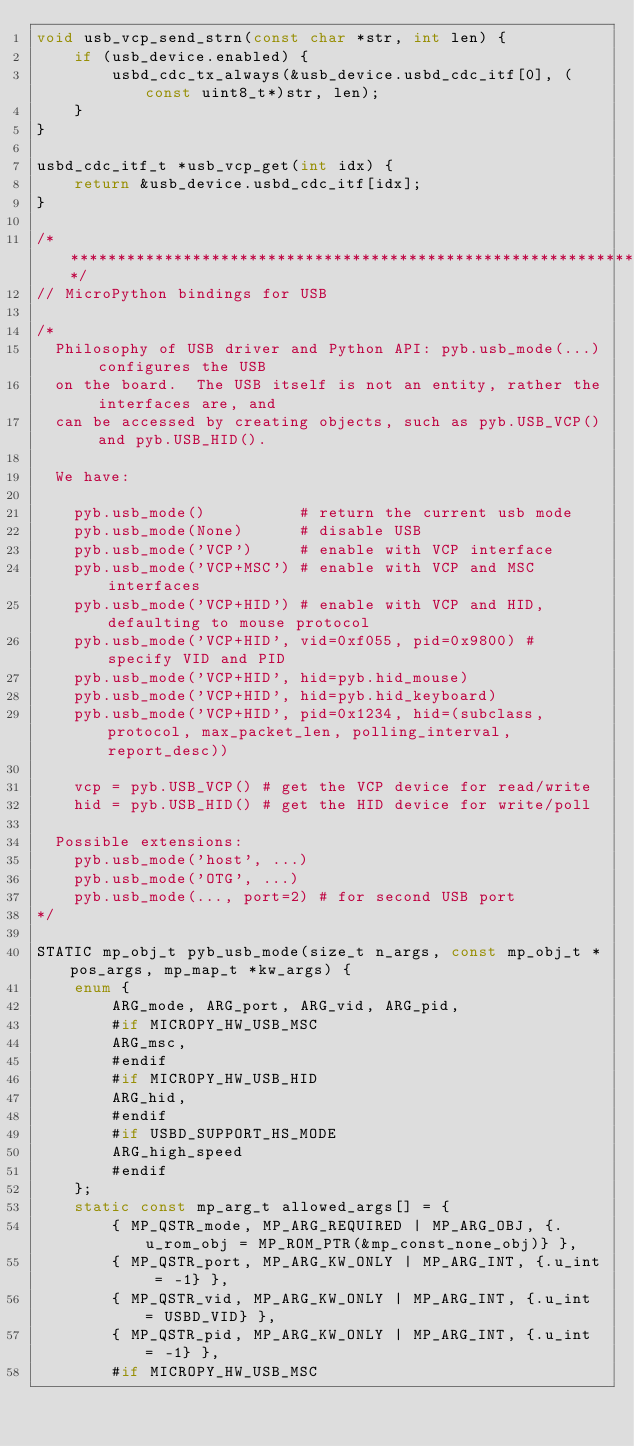<code> <loc_0><loc_0><loc_500><loc_500><_C_>void usb_vcp_send_strn(const char *str, int len) {
    if (usb_device.enabled) {
        usbd_cdc_tx_always(&usb_device.usbd_cdc_itf[0], (const uint8_t*)str, len);
    }
}

usbd_cdc_itf_t *usb_vcp_get(int idx) {
    return &usb_device.usbd_cdc_itf[idx];
}

/******************************************************************************/
// MicroPython bindings for USB

/*
  Philosophy of USB driver and Python API: pyb.usb_mode(...) configures the USB
  on the board.  The USB itself is not an entity, rather the interfaces are, and
  can be accessed by creating objects, such as pyb.USB_VCP() and pyb.USB_HID().

  We have:

    pyb.usb_mode()          # return the current usb mode
    pyb.usb_mode(None)      # disable USB
    pyb.usb_mode('VCP')     # enable with VCP interface
    pyb.usb_mode('VCP+MSC') # enable with VCP and MSC interfaces
    pyb.usb_mode('VCP+HID') # enable with VCP and HID, defaulting to mouse protocol
    pyb.usb_mode('VCP+HID', vid=0xf055, pid=0x9800) # specify VID and PID
    pyb.usb_mode('VCP+HID', hid=pyb.hid_mouse)
    pyb.usb_mode('VCP+HID', hid=pyb.hid_keyboard)
    pyb.usb_mode('VCP+HID', pid=0x1234, hid=(subclass, protocol, max_packet_len, polling_interval, report_desc))

    vcp = pyb.USB_VCP() # get the VCP device for read/write
    hid = pyb.USB_HID() # get the HID device for write/poll

  Possible extensions:
    pyb.usb_mode('host', ...)
    pyb.usb_mode('OTG', ...)
    pyb.usb_mode(..., port=2) # for second USB port
*/

STATIC mp_obj_t pyb_usb_mode(size_t n_args, const mp_obj_t *pos_args, mp_map_t *kw_args) {
    enum {
        ARG_mode, ARG_port, ARG_vid, ARG_pid,
        #if MICROPY_HW_USB_MSC
        ARG_msc,
        #endif
        #if MICROPY_HW_USB_HID
        ARG_hid,
        #endif
        #if USBD_SUPPORT_HS_MODE
        ARG_high_speed
        #endif
    };
    static const mp_arg_t allowed_args[] = {
        { MP_QSTR_mode, MP_ARG_REQUIRED | MP_ARG_OBJ, {.u_rom_obj = MP_ROM_PTR(&mp_const_none_obj)} },
        { MP_QSTR_port, MP_ARG_KW_ONLY | MP_ARG_INT, {.u_int = -1} },
        { MP_QSTR_vid, MP_ARG_KW_ONLY | MP_ARG_INT, {.u_int = USBD_VID} },
        { MP_QSTR_pid, MP_ARG_KW_ONLY | MP_ARG_INT, {.u_int = -1} },
        #if MICROPY_HW_USB_MSC</code> 